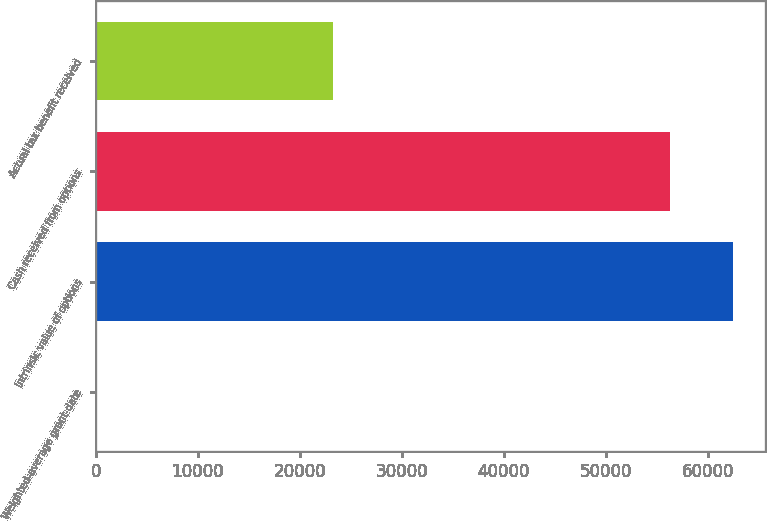Convert chart. <chart><loc_0><loc_0><loc_500><loc_500><bar_chart><fcel>Weighted-average grant-date<fcel>Intrinsic value of options<fcel>Cash received from options<fcel>Actual tax benefit received<nl><fcel>14.77<fcel>62415.4<fcel>56294<fcel>23232<nl></chart> 